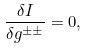<formula> <loc_0><loc_0><loc_500><loc_500>\frac { \delta I } { \delta g ^ { \pm \pm } } = 0 ,</formula> 